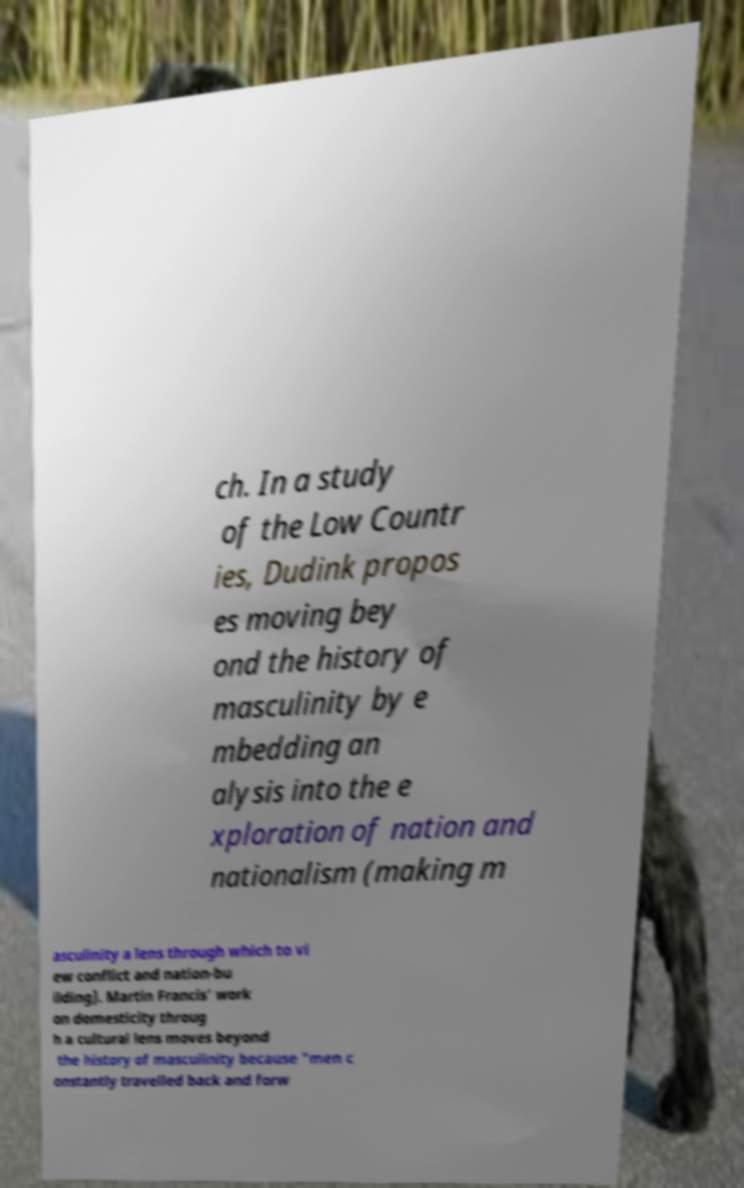Could you extract and type out the text from this image? ch. In a study of the Low Countr ies, Dudink propos es moving bey ond the history of masculinity by e mbedding an alysis into the e xploration of nation and nationalism (making m asculinity a lens through which to vi ew conflict and nation-bu ilding). Martin Francis' work on domesticity throug h a cultural lens moves beyond the history of masculinity because "men c onstantly travelled back and forw 